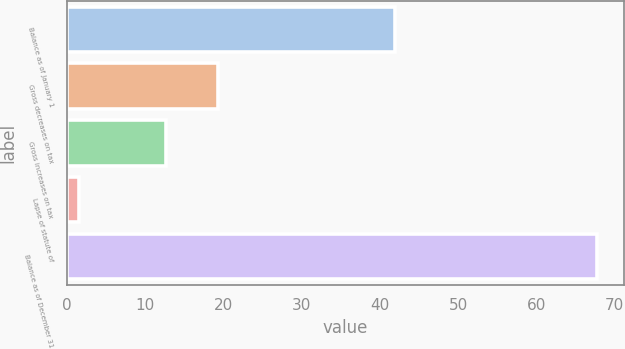Convert chart to OTSL. <chart><loc_0><loc_0><loc_500><loc_500><bar_chart><fcel>Balance as of January 1<fcel>Gross decreases on tax<fcel>Gross increases on tax<fcel>Lapse of statute of<fcel>Balance as of December 31<nl><fcel>41.9<fcel>19.33<fcel>12.7<fcel>1.5<fcel>67.8<nl></chart> 